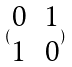<formula> <loc_0><loc_0><loc_500><loc_500>( \begin{matrix} 0 & 1 \\ 1 & 0 \end{matrix} )</formula> 